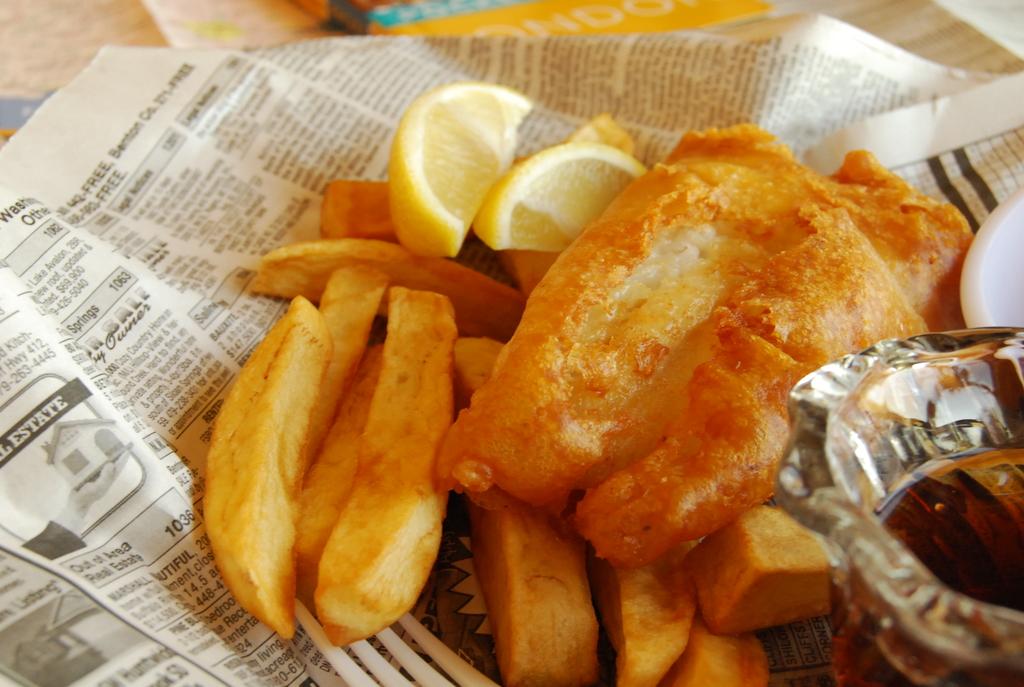Does the newspaper have a real estate ad?
Provide a short and direct response. Yes. 